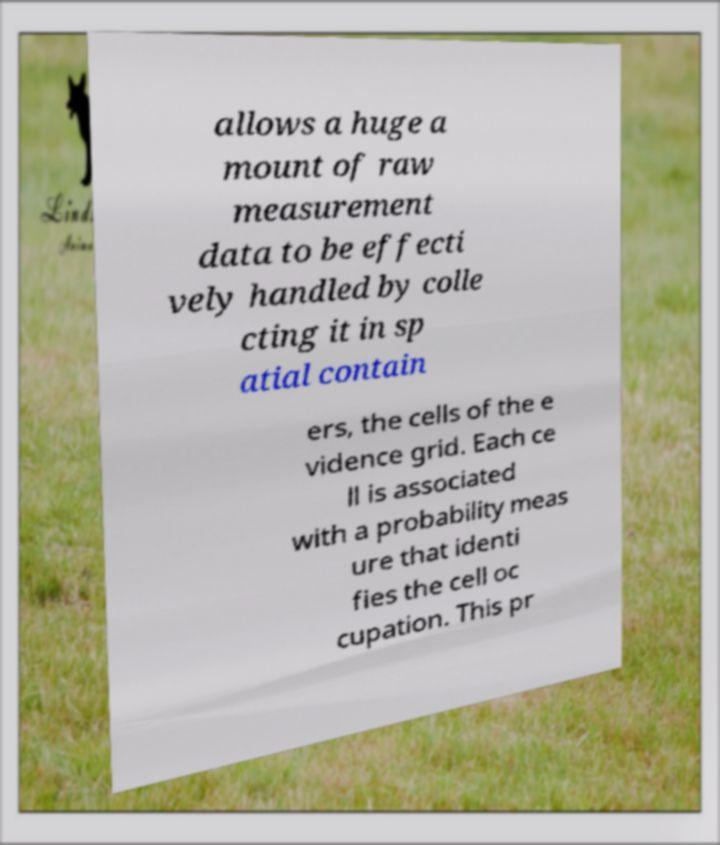Please identify and transcribe the text found in this image. allows a huge a mount of raw measurement data to be effecti vely handled by colle cting it in sp atial contain ers, the cells of the e vidence grid. Each ce ll is associated with a probability meas ure that identi fies the cell oc cupation. This pr 